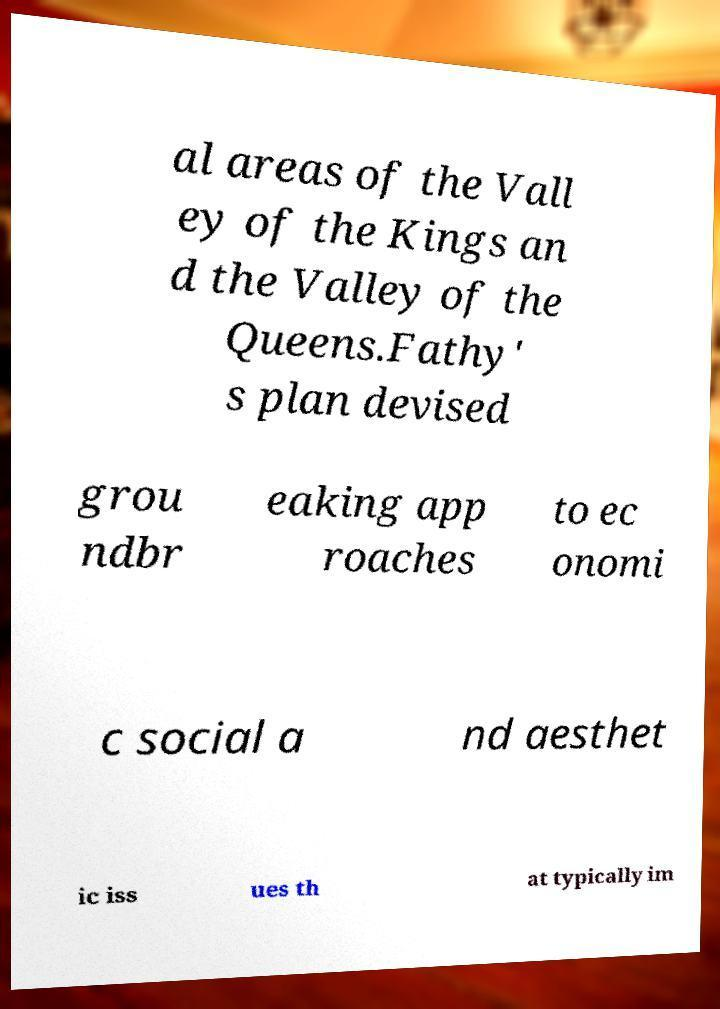There's text embedded in this image that I need extracted. Can you transcribe it verbatim? al areas of the Vall ey of the Kings an d the Valley of the Queens.Fathy' s plan devised grou ndbr eaking app roaches to ec onomi c social a nd aesthet ic iss ues th at typically im 